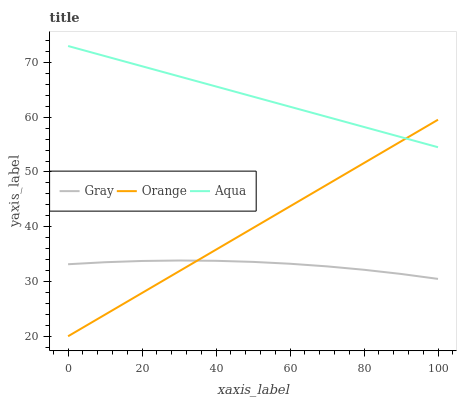Does Aqua have the minimum area under the curve?
Answer yes or no. No. Does Gray have the maximum area under the curve?
Answer yes or no. No. Is Aqua the smoothest?
Answer yes or no. No. Is Aqua the roughest?
Answer yes or no. No. Does Gray have the lowest value?
Answer yes or no. No. Does Gray have the highest value?
Answer yes or no. No. Is Gray less than Aqua?
Answer yes or no. Yes. Is Aqua greater than Gray?
Answer yes or no. Yes. Does Gray intersect Aqua?
Answer yes or no. No. 